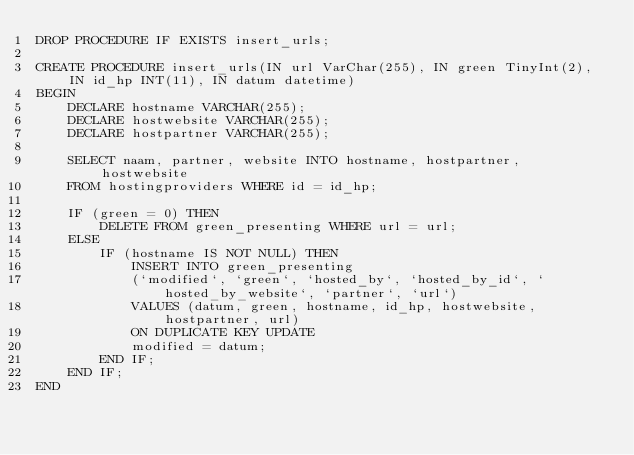<code> <loc_0><loc_0><loc_500><loc_500><_SQL_>DROP PROCEDURE IF EXISTS insert_urls;

CREATE PROCEDURE insert_urls(IN url VarChar(255), IN green TinyInt(2), IN id_hp INT(11), IN datum datetime)
BEGIN
    DECLARE hostname VARCHAR(255);
    DECLARE hostwebsite VARCHAR(255);
    DECLARE hostpartner VARCHAR(255);

    SELECT naam, partner, website INTO hostname, hostpartner, hostwebsite
    FROM hostingproviders WHERE id = id_hp;

    IF (green = 0) THEN
        DELETE FROM green_presenting WHERE url = url;
    ELSE
        IF (hostname IS NOT NULL) THEN
            INSERT INTO green_presenting
            (`modified`, `green`, `hosted_by`, `hosted_by_id`, `hosted_by_website`, `partner`, `url`)
            VALUES (datum, green, hostname, id_hp, hostwebsite, hostpartner, url)
            ON DUPLICATE KEY UPDATE
            modified = datum;
        END IF;
    END IF;
END
</code> 